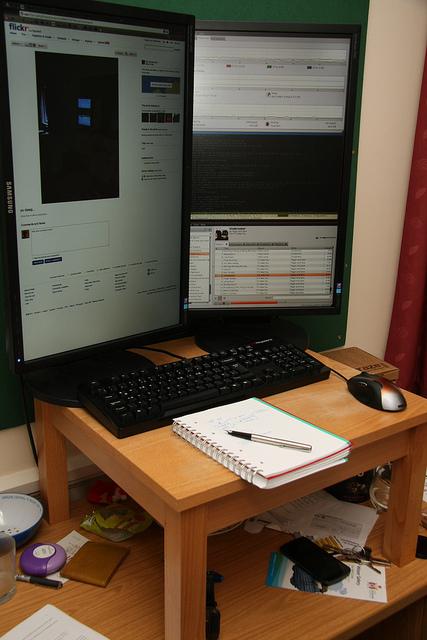What is in front of the keyboard?
Be succinct. Notebook. How many computer monitors are on the desk?
Quick response, please. 3. What are the computers on?
Quick response, please. Desk. What color is the keyboard?
Keep it brief. Black. 